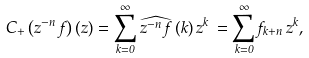<formula> <loc_0><loc_0><loc_500><loc_500>C _ { + } \left ( z ^ { - n } \, f \right ) ( z ) = \sum _ { k = 0 } ^ { \infty } \widehat { z ^ { - n } \, f } \, ( k ) \, z ^ { k } \, = \sum _ { k = 0 } ^ { \infty } f _ { k + n } \, z ^ { k } ,</formula> 